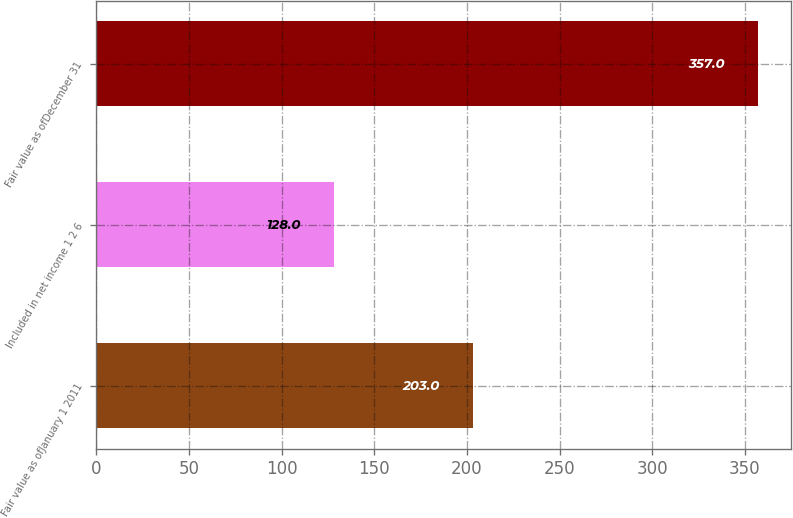Convert chart. <chart><loc_0><loc_0><loc_500><loc_500><bar_chart><fcel>Fair value as ofJanuary 1 2011<fcel>Included in net income 1 2 6<fcel>Fair value as ofDecember 31<nl><fcel>203<fcel>128<fcel>357<nl></chart> 